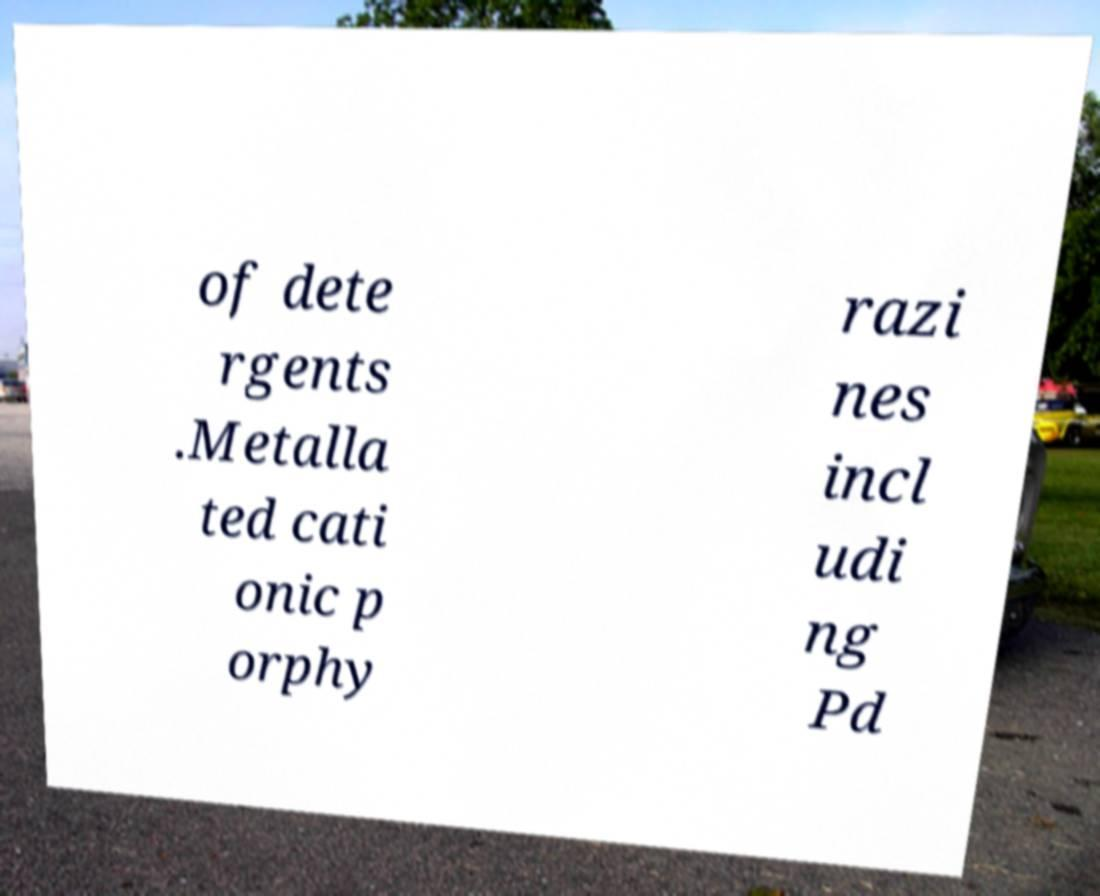There's text embedded in this image that I need extracted. Can you transcribe it verbatim? of dete rgents .Metalla ted cati onic p orphy razi nes incl udi ng Pd 